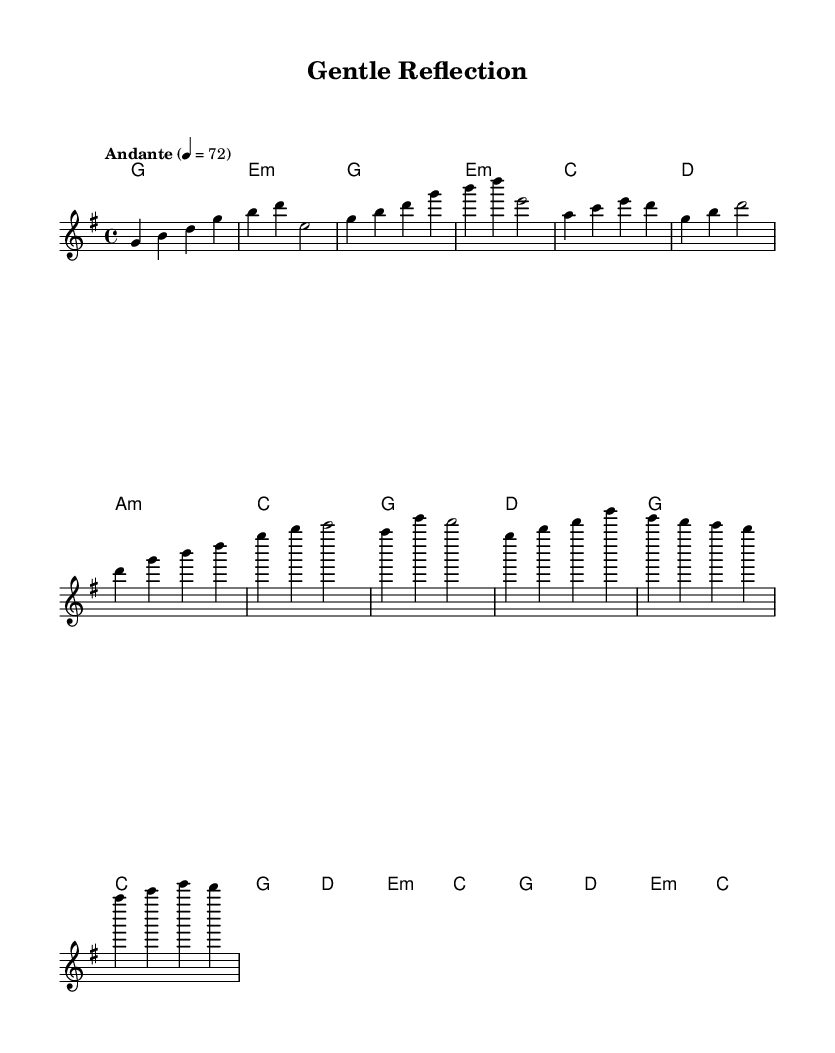What is the key signature of this music? The key signature is G major, which has one sharp (F#). This is determined by looking at the beginning of the staff where the key signature is indicated.
Answer: G major What is the time signature of this music? The time signature is 4/4, indicated at the beginning of the sheet music. This means there are four beats in each measure, and the quarter note gets one beat.
Answer: 4/4 What is the tempo marking for the music? The tempo is marked as "Andante" at 4 beats per minute, indicating a moderate pace. This information is present right before the global settings in the score.
Answer: Andante 4 = 72 How many measures are in the chorus section of the music? The chorus consists of 8 measures. By counting the measures from the start of the chorus (after the verse), we can identify the beginning and end of this section.
Answer: 8 What is the starting note of the melody? The melody starts on the note G, which is the first note indicated in the melody line at the start of the piece.
Answer: G What chord follows the first measure in the verse? The chord that follows the first measure in the verse is E minor. This can be found in the harmonies section, where each chord is laid out sequentially.
Answer: E minor What type of musical piece is represented in this sheet music? This piece represents a K-Pop ballad, characterized by its soothing melodies and emotional content. This is inferred from the title "Gentle Reflection" and the overall style of the music.
Answer: K-Pop ballad 